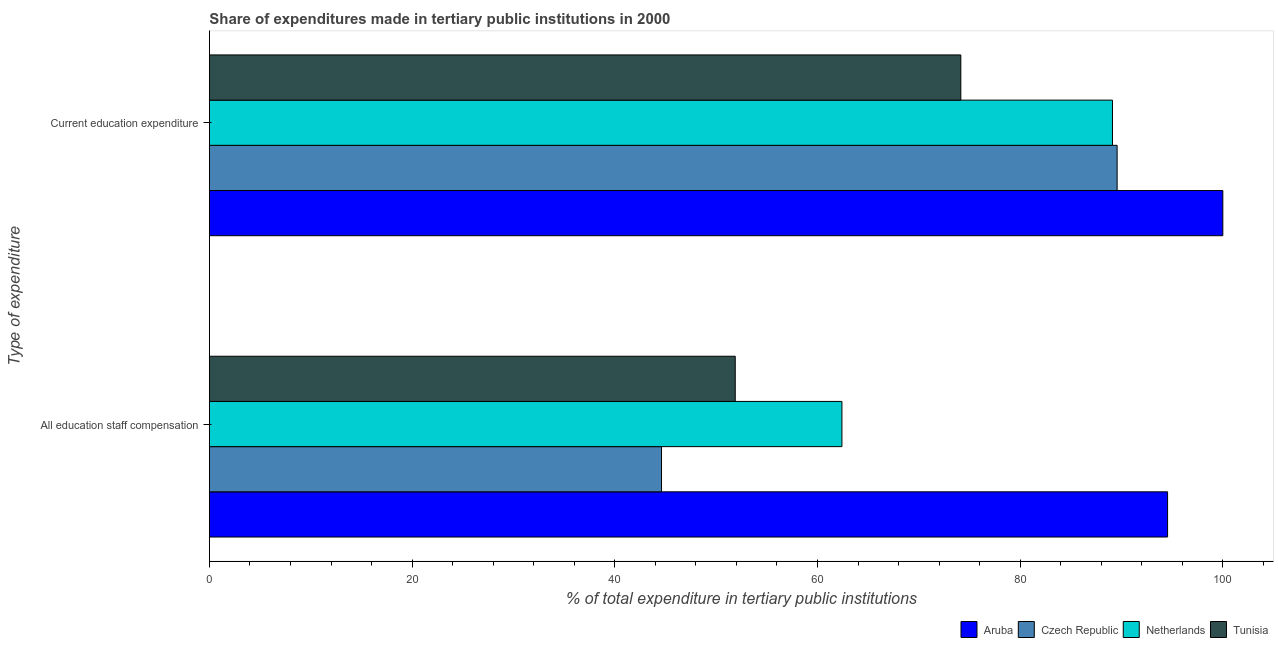How many groups of bars are there?
Your answer should be very brief. 2. What is the label of the 2nd group of bars from the top?
Ensure brevity in your answer.  All education staff compensation. What is the expenditure in education in Czech Republic?
Provide a short and direct response. 89.57. Across all countries, what is the maximum expenditure in staff compensation?
Provide a short and direct response. 94.55. Across all countries, what is the minimum expenditure in education?
Provide a succinct answer. 74.15. In which country was the expenditure in staff compensation maximum?
Give a very brief answer. Aruba. In which country was the expenditure in staff compensation minimum?
Give a very brief answer. Czech Republic. What is the total expenditure in staff compensation in the graph?
Provide a short and direct response. 253.46. What is the difference between the expenditure in staff compensation in Aruba and that in Czech Republic?
Offer a terse response. 49.94. What is the difference between the expenditure in education in Aruba and the expenditure in staff compensation in Netherlands?
Keep it short and to the point. 37.58. What is the average expenditure in staff compensation per country?
Make the answer very short. 63.36. What is the difference between the expenditure in education and expenditure in staff compensation in Aruba?
Your answer should be compact. 5.45. What is the ratio of the expenditure in education in Czech Republic to that in Aruba?
Offer a terse response. 0.9. What does the 3rd bar from the top in All education staff compensation represents?
Keep it short and to the point. Czech Republic. What does the 2nd bar from the bottom in All education staff compensation represents?
Your answer should be very brief. Czech Republic. How many bars are there?
Make the answer very short. 8. Are all the bars in the graph horizontal?
Provide a succinct answer. Yes. How many countries are there in the graph?
Make the answer very short. 4. What is the difference between two consecutive major ticks on the X-axis?
Keep it short and to the point. 20. Does the graph contain grids?
Your answer should be compact. No. What is the title of the graph?
Your answer should be very brief. Share of expenditures made in tertiary public institutions in 2000. What is the label or title of the X-axis?
Make the answer very short. % of total expenditure in tertiary public institutions. What is the label or title of the Y-axis?
Provide a succinct answer. Type of expenditure. What is the % of total expenditure in tertiary public institutions in Aruba in All education staff compensation?
Your answer should be compact. 94.55. What is the % of total expenditure in tertiary public institutions of Czech Republic in All education staff compensation?
Provide a short and direct response. 44.61. What is the % of total expenditure in tertiary public institutions in Netherlands in All education staff compensation?
Provide a short and direct response. 62.41. What is the % of total expenditure in tertiary public institutions of Tunisia in All education staff compensation?
Provide a short and direct response. 51.88. What is the % of total expenditure in tertiary public institutions of Aruba in Current education expenditure?
Your response must be concise. 100. What is the % of total expenditure in tertiary public institutions in Czech Republic in Current education expenditure?
Your response must be concise. 89.57. What is the % of total expenditure in tertiary public institutions in Netherlands in Current education expenditure?
Give a very brief answer. 89.11. What is the % of total expenditure in tertiary public institutions of Tunisia in Current education expenditure?
Offer a terse response. 74.15. Across all Type of expenditure, what is the maximum % of total expenditure in tertiary public institutions in Aruba?
Provide a short and direct response. 100. Across all Type of expenditure, what is the maximum % of total expenditure in tertiary public institutions of Czech Republic?
Ensure brevity in your answer.  89.57. Across all Type of expenditure, what is the maximum % of total expenditure in tertiary public institutions in Netherlands?
Offer a very short reply. 89.11. Across all Type of expenditure, what is the maximum % of total expenditure in tertiary public institutions in Tunisia?
Keep it short and to the point. 74.15. Across all Type of expenditure, what is the minimum % of total expenditure in tertiary public institutions in Aruba?
Your answer should be very brief. 94.55. Across all Type of expenditure, what is the minimum % of total expenditure in tertiary public institutions in Czech Republic?
Make the answer very short. 44.61. Across all Type of expenditure, what is the minimum % of total expenditure in tertiary public institutions in Netherlands?
Your answer should be compact. 62.41. Across all Type of expenditure, what is the minimum % of total expenditure in tertiary public institutions in Tunisia?
Ensure brevity in your answer.  51.88. What is the total % of total expenditure in tertiary public institutions of Aruba in the graph?
Offer a very short reply. 194.55. What is the total % of total expenditure in tertiary public institutions of Czech Republic in the graph?
Offer a very short reply. 134.18. What is the total % of total expenditure in tertiary public institutions in Netherlands in the graph?
Ensure brevity in your answer.  151.52. What is the total % of total expenditure in tertiary public institutions in Tunisia in the graph?
Keep it short and to the point. 126.03. What is the difference between the % of total expenditure in tertiary public institutions in Aruba in All education staff compensation and that in Current education expenditure?
Your answer should be very brief. -5.45. What is the difference between the % of total expenditure in tertiary public institutions of Czech Republic in All education staff compensation and that in Current education expenditure?
Your answer should be compact. -44.96. What is the difference between the % of total expenditure in tertiary public institutions in Netherlands in All education staff compensation and that in Current education expenditure?
Your answer should be very brief. -26.7. What is the difference between the % of total expenditure in tertiary public institutions in Tunisia in All education staff compensation and that in Current education expenditure?
Make the answer very short. -22.26. What is the difference between the % of total expenditure in tertiary public institutions of Aruba in All education staff compensation and the % of total expenditure in tertiary public institutions of Czech Republic in Current education expenditure?
Provide a short and direct response. 4.98. What is the difference between the % of total expenditure in tertiary public institutions of Aruba in All education staff compensation and the % of total expenditure in tertiary public institutions of Netherlands in Current education expenditure?
Provide a short and direct response. 5.44. What is the difference between the % of total expenditure in tertiary public institutions of Aruba in All education staff compensation and the % of total expenditure in tertiary public institutions of Tunisia in Current education expenditure?
Keep it short and to the point. 20.4. What is the difference between the % of total expenditure in tertiary public institutions of Czech Republic in All education staff compensation and the % of total expenditure in tertiary public institutions of Netherlands in Current education expenditure?
Your answer should be very brief. -44.5. What is the difference between the % of total expenditure in tertiary public institutions in Czech Republic in All education staff compensation and the % of total expenditure in tertiary public institutions in Tunisia in Current education expenditure?
Your response must be concise. -29.53. What is the difference between the % of total expenditure in tertiary public institutions of Netherlands in All education staff compensation and the % of total expenditure in tertiary public institutions of Tunisia in Current education expenditure?
Give a very brief answer. -11.73. What is the average % of total expenditure in tertiary public institutions of Aruba per Type of expenditure?
Make the answer very short. 97.27. What is the average % of total expenditure in tertiary public institutions of Czech Republic per Type of expenditure?
Offer a terse response. 67.09. What is the average % of total expenditure in tertiary public institutions in Netherlands per Type of expenditure?
Your answer should be compact. 75.76. What is the average % of total expenditure in tertiary public institutions in Tunisia per Type of expenditure?
Offer a terse response. 63.02. What is the difference between the % of total expenditure in tertiary public institutions of Aruba and % of total expenditure in tertiary public institutions of Czech Republic in All education staff compensation?
Give a very brief answer. 49.94. What is the difference between the % of total expenditure in tertiary public institutions of Aruba and % of total expenditure in tertiary public institutions of Netherlands in All education staff compensation?
Keep it short and to the point. 32.13. What is the difference between the % of total expenditure in tertiary public institutions of Aruba and % of total expenditure in tertiary public institutions of Tunisia in All education staff compensation?
Your response must be concise. 42.66. What is the difference between the % of total expenditure in tertiary public institutions in Czech Republic and % of total expenditure in tertiary public institutions in Netherlands in All education staff compensation?
Your answer should be very brief. -17.8. What is the difference between the % of total expenditure in tertiary public institutions of Czech Republic and % of total expenditure in tertiary public institutions of Tunisia in All education staff compensation?
Provide a succinct answer. -7.27. What is the difference between the % of total expenditure in tertiary public institutions in Netherlands and % of total expenditure in tertiary public institutions in Tunisia in All education staff compensation?
Keep it short and to the point. 10.53. What is the difference between the % of total expenditure in tertiary public institutions of Aruba and % of total expenditure in tertiary public institutions of Czech Republic in Current education expenditure?
Your response must be concise. 10.43. What is the difference between the % of total expenditure in tertiary public institutions of Aruba and % of total expenditure in tertiary public institutions of Netherlands in Current education expenditure?
Your answer should be very brief. 10.89. What is the difference between the % of total expenditure in tertiary public institutions in Aruba and % of total expenditure in tertiary public institutions in Tunisia in Current education expenditure?
Your answer should be very brief. 25.85. What is the difference between the % of total expenditure in tertiary public institutions of Czech Republic and % of total expenditure in tertiary public institutions of Netherlands in Current education expenditure?
Offer a terse response. 0.46. What is the difference between the % of total expenditure in tertiary public institutions of Czech Republic and % of total expenditure in tertiary public institutions of Tunisia in Current education expenditure?
Your answer should be compact. 15.42. What is the difference between the % of total expenditure in tertiary public institutions of Netherlands and % of total expenditure in tertiary public institutions of Tunisia in Current education expenditure?
Your answer should be very brief. 14.96. What is the ratio of the % of total expenditure in tertiary public institutions of Aruba in All education staff compensation to that in Current education expenditure?
Offer a very short reply. 0.95. What is the ratio of the % of total expenditure in tertiary public institutions of Czech Republic in All education staff compensation to that in Current education expenditure?
Your answer should be compact. 0.5. What is the ratio of the % of total expenditure in tertiary public institutions in Netherlands in All education staff compensation to that in Current education expenditure?
Your answer should be compact. 0.7. What is the ratio of the % of total expenditure in tertiary public institutions in Tunisia in All education staff compensation to that in Current education expenditure?
Your answer should be very brief. 0.7. What is the difference between the highest and the second highest % of total expenditure in tertiary public institutions in Aruba?
Your answer should be compact. 5.45. What is the difference between the highest and the second highest % of total expenditure in tertiary public institutions in Czech Republic?
Offer a very short reply. 44.96. What is the difference between the highest and the second highest % of total expenditure in tertiary public institutions in Netherlands?
Keep it short and to the point. 26.7. What is the difference between the highest and the second highest % of total expenditure in tertiary public institutions of Tunisia?
Keep it short and to the point. 22.26. What is the difference between the highest and the lowest % of total expenditure in tertiary public institutions in Aruba?
Provide a short and direct response. 5.45. What is the difference between the highest and the lowest % of total expenditure in tertiary public institutions in Czech Republic?
Your response must be concise. 44.96. What is the difference between the highest and the lowest % of total expenditure in tertiary public institutions of Netherlands?
Give a very brief answer. 26.7. What is the difference between the highest and the lowest % of total expenditure in tertiary public institutions of Tunisia?
Give a very brief answer. 22.26. 